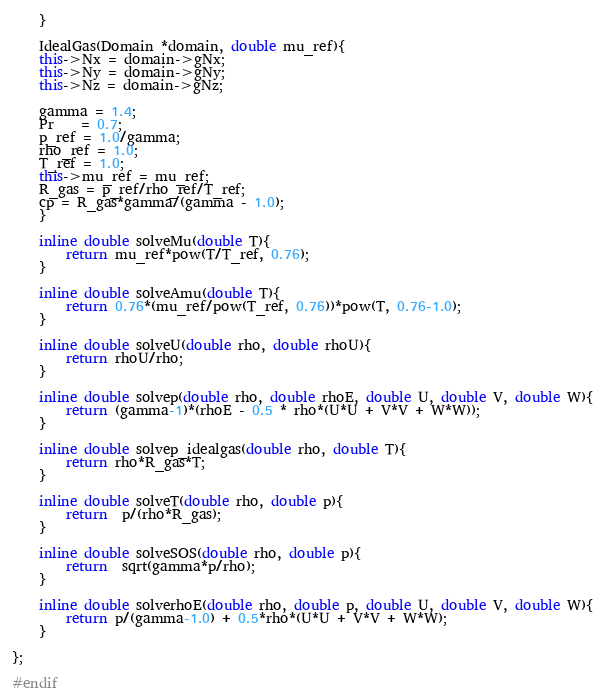Convert code to text. <code><loc_0><loc_0><loc_500><loc_500><_C++_>    }

    IdealGas(Domain *domain, double mu_ref){
	this->Nx = domain->gNx; 
	this->Ny = domain->gNy;
	this->Nz = domain->gNz;

	gamma = 1.4;
	Pr    = 0.7;
	p_ref = 1.0/gamma;
	rho_ref = 1.0;
	T_ref = 1.0;
	this->mu_ref = mu_ref;
	R_gas = p_ref/rho_ref/T_ref;
	cp = R_gas*gamma/(gamma - 1.0);
    } 

    inline double solveMu(double T){
        return mu_ref*pow(T/T_ref, 0.76);
    }

    inline double solveAmu(double T){
        return 0.76*(mu_ref/pow(T_ref, 0.76))*pow(T, 0.76-1.0);
    } 

    inline double solveU(double rho, double rhoU){
        return rhoU/rho;
    }

    inline double solvep(double rho, double rhoE, double U, double V, double W){
        return (gamma-1)*(rhoE - 0.5 * rho*(U*U + V*V + W*W));
    }

    inline double solvep_idealgas(double rho, double T){
        return rho*R_gas*T;
    }

    inline double solveT(double rho, double p){
        return  p/(rho*R_gas);
    }

    inline double solveSOS(double rho, double p){
        return  sqrt(gamma*p/rho);
    }

    inline double solverhoE(double rho, double p, double U, double V, double W){
        return p/(gamma-1.0) + 0.5*rho*(U*U + V*V + W*W);
    }

};

#endif
</code> 